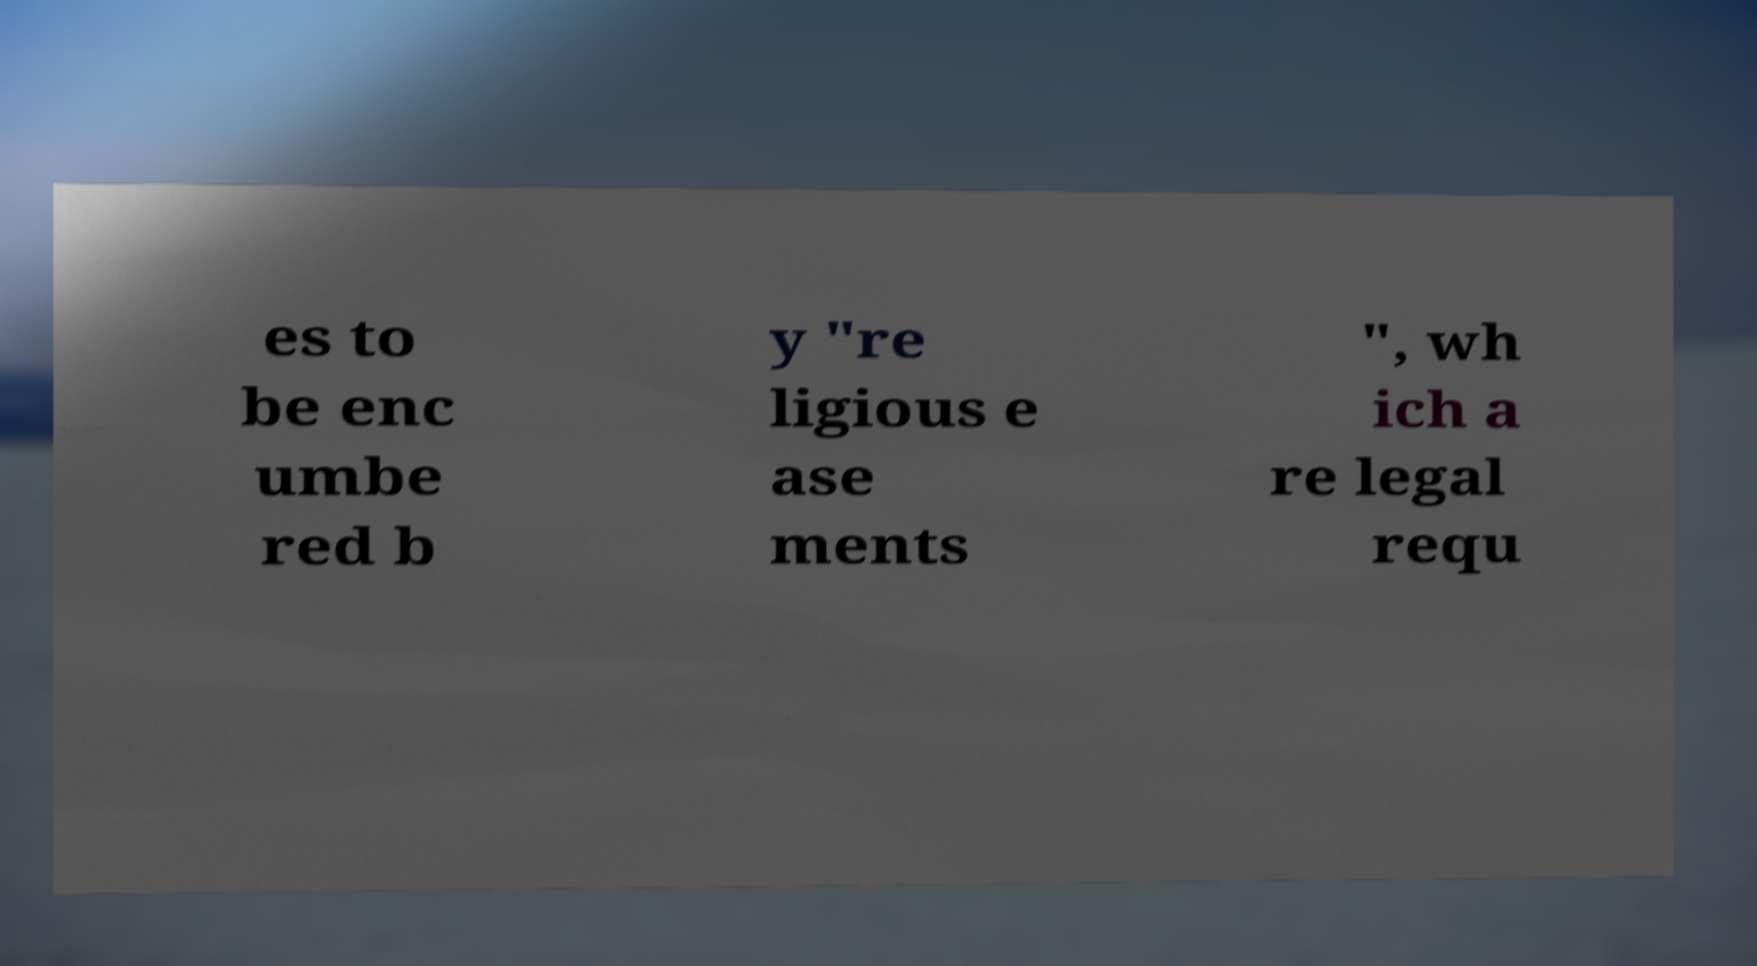There's text embedded in this image that I need extracted. Can you transcribe it verbatim? es to be enc umbe red b y "re ligious e ase ments ", wh ich a re legal requ 